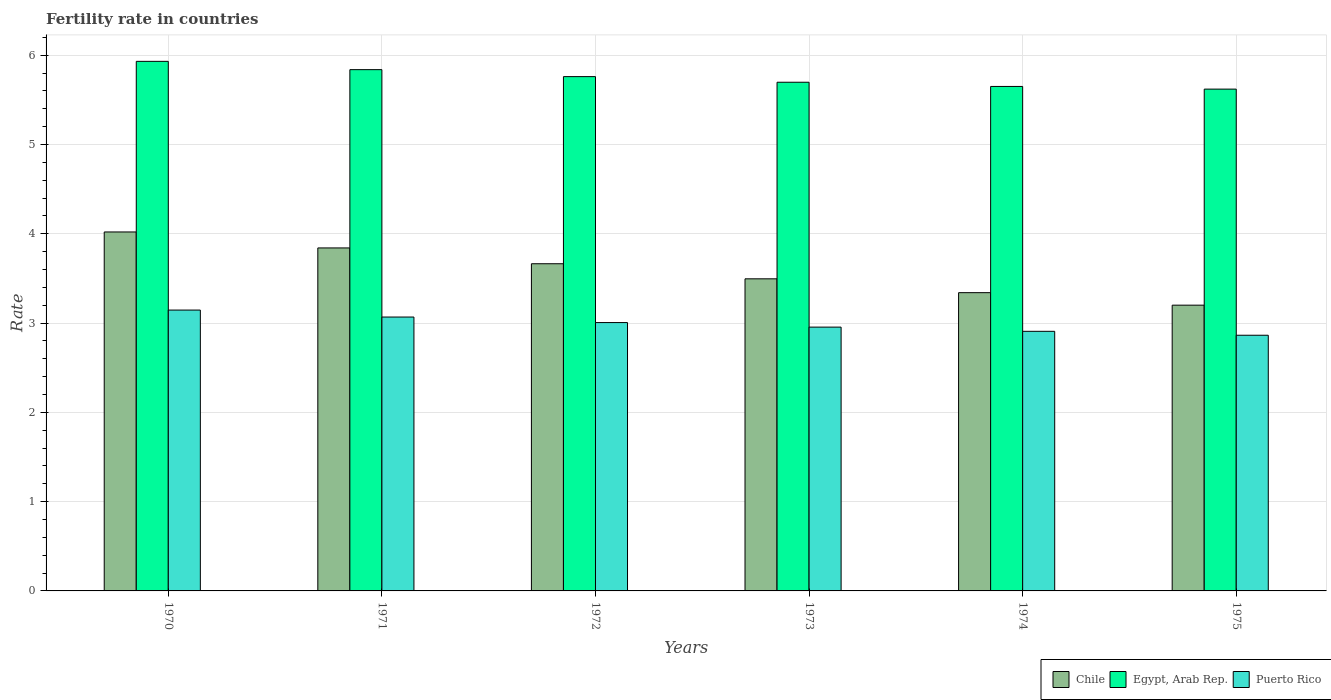How many different coloured bars are there?
Offer a very short reply. 3. Are the number of bars on each tick of the X-axis equal?
Keep it short and to the point. Yes. How many bars are there on the 3rd tick from the left?
Keep it short and to the point. 3. What is the fertility rate in Puerto Rico in 1973?
Give a very brief answer. 2.96. Across all years, what is the maximum fertility rate in Puerto Rico?
Your answer should be compact. 3.15. Across all years, what is the minimum fertility rate in Egypt, Arab Rep.?
Make the answer very short. 5.62. In which year was the fertility rate in Puerto Rico minimum?
Make the answer very short. 1975. What is the total fertility rate in Egypt, Arab Rep. in the graph?
Offer a terse response. 34.5. What is the difference between the fertility rate in Puerto Rico in 1972 and that in 1975?
Offer a terse response. 0.14. What is the difference between the fertility rate in Egypt, Arab Rep. in 1970 and the fertility rate in Puerto Rico in 1971?
Provide a succinct answer. 2.86. What is the average fertility rate in Puerto Rico per year?
Give a very brief answer. 2.99. In the year 1975, what is the difference between the fertility rate in Puerto Rico and fertility rate in Chile?
Keep it short and to the point. -0.34. In how many years, is the fertility rate in Chile greater than 4.8?
Offer a very short reply. 0. What is the ratio of the fertility rate in Chile in 1970 to that in 1975?
Your answer should be compact. 1.26. Is the fertility rate in Puerto Rico in 1971 less than that in 1974?
Offer a terse response. No. What is the difference between the highest and the second highest fertility rate in Chile?
Provide a succinct answer. 0.18. What is the difference between the highest and the lowest fertility rate in Chile?
Provide a succinct answer. 0.82. Is the sum of the fertility rate in Chile in 1971 and 1974 greater than the maximum fertility rate in Egypt, Arab Rep. across all years?
Ensure brevity in your answer.  Yes. What does the 3rd bar from the left in 1971 represents?
Your answer should be very brief. Puerto Rico. What does the 2nd bar from the right in 1975 represents?
Ensure brevity in your answer.  Egypt, Arab Rep. How many bars are there?
Give a very brief answer. 18. Are all the bars in the graph horizontal?
Provide a short and direct response. No. How many years are there in the graph?
Ensure brevity in your answer.  6. Are the values on the major ticks of Y-axis written in scientific E-notation?
Provide a succinct answer. No. Where does the legend appear in the graph?
Provide a short and direct response. Bottom right. How many legend labels are there?
Offer a terse response. 3. How are the legend labels stacked?
Your answer should be compact. Horizontal. What is the title of the graph?
Offer a very short reply. Fertility rate in countries. What is the label or title of the X-axis?
Your answer should be very brief. Years. What is the label or title of the Y-axis?
Your response must be concise. Rate. What is the Rate in Chile in 1970?
Provide a short and direct response. 4.02. What is the Rate in Egypt, Arab Rep. in 1970?
Provide a short and direct response. 5.93. What is the Rate of Puerto Rico in 1970?
Your response must be concise. 3.15. What is the Rate in Chile in 1971?
Make the answer very short. 3.84. What is the Rate in Egypt, Arab Rep. in 1971?
Keep it short and to the point. 5.84. What is the Rate in Puerto Rico in 1971?
Offer a very short reply. 3.07. What is the Rate in Chile in 1972?
Your response must be concise. 3.67. What is the Rate in Egypt, Arab Rep. in 1972?
Ensure brevity in your answer.  5.76. What is the Rate in Puerto Rico in 1972?
Ensure brevity in your answer.  3.01. What is the Rate of Chile in 1973?
Make the answer very short. 3.5. What is the Rate of Egypt, Arab Rep. in 1973?
Ensure brevity in your answer.  5.7. What is the Rate in Puerto Rico in 1973?
Offer a very short reply. 2.96. What is the Rate of Chile in 1974?
Offer a terse response. 3.34. What is the Rate in Egypt, Arab Rep. in 1974?
Offer a very short reply. 5.65. What is the Rate of Puerto Rico in 1974?
Your answer should be compact. 2.91. What is the Rate in Chile in 1975?
Offer a very short reply. 3.2. What is the Rate of Egypt, Arab Rep. in 1975?
Make the answer very short. 5.62. What is the Rate in Puerto Rico in 1975?
Offer a terse response. 2.86. Across all years, what is the maximum Rate of Chile?
Provide a succinct answer. 4.02. Across all years, what is the maximum Rate of Egypt, Arab Rep.?
Your response must be concise. 5.93. Across all years, what is the maximum Rate of Puerto Rico?
Provide a short and direct response. 3.15. Across all years, what is the minimum Rate of Chile?
Offer a very short reply. 3.2. Across all years, what is the minimum Rate in Egypt, Arab Rep.?
Offer a terse response. 5.62. Across all years, what is the minimum Rate in Puerto Rico?
Offer a very short reply. 2.86. What is the total Rate in Chile in the graph?
Offer a terse response. 21.57. What is the total Rate in Egypt, Arab Rep. in the graph?
Offer a very short reply. 34.5. What is the total Rate in Puerto Rico in the graph?
Offer a very short reply. 17.95. What is the difference between the Rate in Chile in 1970 and that in 1971?
Your answer should be compact. 0.18. What is the difference between the Rate of Egypt, Arab Rep. in 1970 and that in 1971?
Ensure brevity in your answer.  0.09. What is the difference between the Rate in Puerto Rico in 1970 and that in 1971?
Ensure brevity in your answer.  0.08. What is the difference between the Rate of Chile in 1970 and that in 1972?
Provide a short and direct response. 0.36. What is the difference between the Rate in Egypt, Arab Rep. in 1970 and that in 1972?
Keep it short and to the point. 0.17. What is the difference between the Rate of Puerto Rico in 1970 and that in 1972?
Make the answer very short. 0.14. What is the difference between the Rate in Chile in 1970 and that in 1973?
Your response must be concise. 0.53. What is the difference between the Rate in Egypt, Arab Rep. in 1970 and that in 1973?
Keep it short and to the point. 0.23. What is the difference between the Rate in Puerto Rico in 1970 and that in 1973?
Give a very brief answer. 0.19. What is the difference between the Rate in Chile in 1970 and that in 1974?
Offer a terse response. 0.68. What is the difference between the Rate of Egypt, Arab Rep. in 1970 and that in 1974?
Your answer should be very brief. 0.28. What is the difference between the Rate in Puerto Rico in 1970 and that in 1974?
Provide a short and direct response. 0.24. What is the difference between the Rate in Chile in 1970 and that in 1975?
Keep it short and to the point. 0.82. What is the difference between the Rate in Egypt, Arab Rep. in 1970 and that in 1975?
Offer a very short reply. 0.31. What is the difference between the Rate in Puerto Rico in 1970 and that in 1975?
Provide a short and direct response. 0.28. What is the difference between the Rate in Chile in 1971 and that in 1972?
Your answer should be compact. 0.18. What is the difference between the Rate in Egypt, Arab Rep. in 1971 and that in 1972?
Provide a succinct answer. 0.08. What is the difference between the Rate of Puerto Rico in 1971 and that in 1972?
Your answer should be very brief. 0.06. What is the difference between the Rate in Chile in 1971 and that in 1973?
Offer a terse response. 0.35. What is the difference between the Rate in Egypt, Arab Rep. in 1971 and that in 1973?
Your answer should be very brief. 0.14. What is the difference between the Rate of Puerto Rico in 1971 and that in 1973?
Your response must be concise. 0.11. What is the difference between the Rate in Chile in 1971 and that in 1974?
Your response must be concise. 0.5. What is the difference between the Rate of Egypt, Arab Rep. in 1971 and that in 1974?
Provide a succinct answer. 0.19. What is the difference between the Rate of Puerto Rico in 1971 and that in 1974?
Provide a succinct answer. 0.16. What is the difference between the Rate of Chile in 1971 and that in 1975?
Provide a short and direct response. 0.64. What is the difference between the Rate of Egypt, Arab Rep. in 1971 and that in 1975?
Offer a terse response. 0.22. What is the difference between the Rate of Puerto Rico in 1971 and that in 1975?
Offer a very short reply. 0.2. What is the difference between the Rate of Chile in 1972 and that in 1973?
Your answer should be compact. 0.17. What is the difference between the Rate in Egypt, Arab Rep. in 1972 and that in 1973?
Provide a succinct answer. 0.06. What is the difference between the Rate of Puerto Rico in 1972 and that in 1973?
Provide a short and direct response. 0.05. What is the difference between the Rate in Chile in 1972 and that in 1974?
Ensure brevity in your answer.  0.32. What is the difference between the Rate of Egypt, Arab Rep. in 1972 and that in 1974?
Your answer should be compact. 0.11. What is the difference between the Rate in Puerto Rico in 1972 and that in 1974?
Provide a short and direct response. 0.1. What is the difference between the Rate of Chile in 1972 and that in 1975?
Offer a terse response. 0.46. What is the difference between the Rate in Egypt, Arab Rep. in 1972 and that in 1975?
Ensure brevity in your answer.  0.14. What is the difference between the Rate in Puerto Rico in 1972 and that in 1975?
Offer a terse response. 0.14. What is the difference between the Rate of Chile in 1973 and that in 1974?
Keep it short and to the point. 0.15. What is the difference between the Rate in Egypt, Arab Rep. in 1973 and that in 1974?
Offer a very short reply. 0.05. What is the difference between the Rate of Puerto Rico in 1973 and that in 1974?
Ensure brevity in your answer.  0.05. What is the difference between the Rate of Chile in 1973 and that in 1975?
Offer a very short reply. 0.29. What is the difference between the Rate in Egypt, Arab Rep. in 1973 and that in 1975?
Your answer should be very brief. 0.08. What is the difference between the Rate of Puerto Rico in 1973 and that in 1975?
Ensure brevity in your answer.  0.09. What is the difference between the Rate of Chile in 1974 and that in 1975?
Give a very brief answer. 0.14. What is the difference between the Rate in Puerto Rico in 1974 and that in 1975?
Provide a succinct answer. 0.04. What is the difference between the Rate in Chile in 1970 and the Rate in Egypt, Arab Rep. in 1971?
Provide a succinct answer. -1.82. What is the difference between the Rate in Chile in 1970 and the Rate in Puerto Rico in 1971?
Offer a very short reply. 0.95. What is the difference between the Rate of Egypt, Arab Rep. in 1970 and the Rate of Puerto Rico in 1971?
Keep it short and to the point. 2.86. What is the difference between the Rate in Chile in 1970 and the Rate in Egypt, Arab Rep. in 1972?
Provide a succinct answer. -1.74. What is the difference between the Rate in Egypt, Arab Rep. in 1970 and the Rate in Puerto Rico in 1972?
Offer a very short reply. 2.93. What is the difference between the Rate in Chile in 1970 and the Rate in Egypt, Arab Rep. in 1973?
Make the answer very short. -1.68. What is the difference between the Rate in Chile in 1970 and the Rate in Puerto Rico in 1973?
Your response must be concise. 1.07. What is the difference between the Rate in Egypt, Arab Rep. in 1970 and the Rate in Puerto Rico in 1973?
Your response must be concise. 2.98. What is the difference between the Rate in Chile in 1970 and the Rate in Egypt, Arab Rep. in 1974?
Give a very brief answer. -1.63. What is the difference between the Rate of Chile in 1970 and the Rate of Puerto Rico in 1974?
Offer a very short reply. 1.11. What is the difference between the Rate of Egypt, Arab Rep. in 1970 and the Rate of Puerto Rico in 1974?
Your answer should be very brief. 3.02. What is the difference between the Rate in Chile in 1970 and the Rate in Puerto Rico in 1975?
Give a very brief answer. 1.16. What is the difference between the Rate in Egypt, Arab Rep. in 1970 and the Rate in Puerto Rico in 1975?
Make the answer very short. 3.07. What is the difference between the Rate in Chile in 1971 and the Rate in Egypt, Arab Rep. in 1972?
Give a very brief answer. -1.92. What is the difference between the Rate of Chile in 1971 and the Rate of Puerto Rico in 1972?
Keep it short and to the point. 0.84. What is the difference between the Rate in Egypt, Arab Rep. in 1971 and the Rate in Puerto Rico in 1972?
Offer a terse response. 2.83. What is the difference between the Rate of Chile in 1971 and the Rate of Egypt, Arab Rep. in 1973?
Give a very brief answer. -1.86. What is the difference between the Rate in Chile in 1971 and the Rate in Puerto Rico in 1973?
Offer a terse response. 0.89. What is the difference between the Rate of Egypt, Arab Rep. in 1971 and the Rate of Puerto Rico in 1973?
Your response must be concise. 2.88. What is the difference between the Rate in Chile in 1971 and the Rate in Egypt, Arab Rep. in 1974?
Make the answer very short. -1.81. What is the difference between the Rate in Chile in 1971 and the Rate in Puerto Rico in 1974?
Offer a very short reply. 0.93. What is the difference between the Rate of Egypt, Arab Rep. in 1971 and the Rate of Puerto Rico in 1974?
Your answer should be very brief. 2.93. What is the difference between the Rate in Chile in 1971 and the Rate in Egypt, Arab Rep. in 1975?
Offer a terse response. -1.78. What is the difference between the Rate of Chile in 1971 and the Rate of Puerto Rico in 1975?
Provide a short and direct response. 0.98. What is the difference between the Rate in Egypt, Arab Rep. in 1971 and the Rate in Puerto Rico in 1975?
Your answer should be compact. 2.98. What is the difference between the Rate in Chile in 1972 and the Rate in Egypt, Arab Rep. in 1973?
Your response must be concise. -2.03. What is the difference between the Rate in Chile in 1972 and the Rate in Puerto Rico in 1973?
Keep it short and to the point. 0.71. What is the difference between the Rate in Egypt, Arab Rep. in 1972 and the Rate in Puerto Rico in 1973?
Your answer should be compact. 2.81. What is the difference between the Rate in Chile in 1972 and the Rate in Egypt, Arab Rep. in 1974?
Provide a short and direct response. -1.99. What is the difference between the Rate in Chile in 1972 and the Rate in Puerto Rico in 1974?
Offer a very short reply. 0.76. What is the difference between the Rate in Egypt, Arab Rep. in 1972 and the Rate in Puerto Rico in 1974?
Ensure brevity in your answer.  2.85. What is the difference between the Rate of Chile in 1972 and the Rate of Egypt, Arab Rep. in 1975?
Provide a short and direct response. -1.96. What is the difference between the Rate of Chile in 1972 and the Rate of Puerto Rico in 1975?
Provide a succinct answer. 0.8. What is the difference between the Rate of Egypt, Arab Rep. in 1972 and the Rate of Puerto Rico in 1975?
Make the answer very short. 2.9. What is the difference between the Rate of Chile in 1973 and the Rate of Egypt, Arab Rep. in 1974?
Ensure brevity in your answer.  -2.15. What is the difference between the Rate of Chile in 1973 and the Rate of Puerto Rico in 1974?
Provide a succinct answer. 0.59. What is the difference between the Rate in Egypt, Arab Rep. in 1973 and the Rate in Puerto Rico in 1974?
Your answer should be very brief. 2.79. What is the difference between the Rate in Chile in 1973 and the Rate in Egypt, Arab Rep. in 1975?
Provide a succinct answer. -2.12. What is the difference between the Rate of Chile in 1973 and the Rate of Puerto Rico in 1975?
Provide a short and direct response. 0.63. What is the difference between the Rate in Egypt, Arab Rep. in 1973 and the Rate in Puerto Rico in 1975?
Your answer should be compact. 2.83. What is the difference between the Rate of Chile in 1974 and the Rate of Egypt, Arab Rep. in 1975?
Your response must be concise. -2.28. What is the difference between the Rate of Chile in 1974 and the Rate of Puerto Rico in 1975?
Your answer should be very brief. 0.48. What is the difference between the Rate of Egypt, Arab Rep. in 1974 and the Rate of Puerto Rico in 1975?
Provide a succinct answer. 2.79. What is the average Rate in Chile per year?
Make the answer very short. 3.59. What is the average Rate in Egypt, Arab Rep. per year?
Make the answer very short. 5.75. What is the average Rate of Puerto Rico per year?
Give a very brief answer. 2.99. In the year 1970, what is the difference between the Rate of Chile and Rate of Egypt, Arab Rep.?
Provide a succinct answer. -1.91. In the year 1970, what is the difference between the Rate of Chile and Rate of Puerto Rico?
Offer a very short reply. 0.88. In the year 1970, what is the difference between the Rate in Egypt, Arab Rep. and Rate in Puerto Rico?
Provide a short and direct response. 2.79. In the year 1971, what is the difference between the Rate of Chile and Rate of Egypt, Arab Rep.?
Make the answer very short. -2. In the year 1971, what is the difference between the Rate of Chile and Rate of Puerto Rico?
Offer a very short reply. 0.77. In the year 1971, what is the difference between the Rate in Egypt, Arab Rep. and Rate in Puerto Rico?
Ensure brevity in your answer.  2.77. In the year 1972, what is the difference between the Rate in Chile and Rate in Egypt, Arab Rep.?
Your response must be concise. -2.1. In the year 1972, what is the difference between the Rate in Chile and Rate in Puerto Rico?
Provide a succinct answer. 0.66. In the year 1972, what is the difference between the Rate of Egypt, Arab Rep. and Rate of Puerto Rico?
Offer a very short reply. 2.75. In the year 1973, what is the difference between the Rate in Chile and Rate in Egypt, Arab Rep.?
Your answer should be compact. -2.2. In the year 1973, what is the difference between the Rate of Chile and Rate of Puerto Rico?
Ensure brevity in your answer.  0.54. In the year 1973, what is the difference between the Rate in Egypt, Arab Rep. and Rate in Puerto Rico?
Your response must be concise. 2.74. In the year 1974, what is the difference between the Rate in Chile and Rate in Egypt, Arab Rep.?
Offer a terse response. -2.31. In the year 1974, what is the difference between the Rate in Chile and Rate in Puerto Rico?
Give a very brief answer. 0.43. In the year 1974, what is the difference between the Rate in Egypt, Arab Rep. and Rate in Puerto Rico?
Ensure brevity in your answer.  2.74. In the year 1975, what is the difference between the Rate in Chile and Rate in Egypt, Arab Rep.?
Your answer should be very brief. -2.42. In the year 1975, what is the difference between the Rate in Chile and Rate in Puerto Rico?
Keep it short and to the point. 0.34. In the year 1975, what is the difference between the Rate in Egypt, Arab Rep. and Rate in Puerto Rico?
Ensure brevity in your answer.  2.76. What is the ratio of the Rate of Chile in 1970 to that in 1971?
Your answer should be compact. 1.05. What is the ratio of the Rate of Egypt, Arab Rep. in 1970 to that in 1971?
Offer a terse response. 1.02. What is the ratio of the Rate in Puerto Rico in 1970 to that in 1971?
Keep it short and to the point. 1.03. What is the ratio of the Rate in Chile in 1970 to that in 1972?
Make the answer very short. 1.1. What is the ratio of the Rate of Egypt, Arab Rep. in 1970 to that in 1972?
Ensure brevity in your answer.  1.03. What is the ratio of the Rate of Puerto Rico in 1970 to that in 1972?
Make the answer very short. 1.05. What is the ratio of the Rate of Chile in 1970 to that in 1973?
Provide a short and direct response. 1.15. What is the ratio of the Rate in Egypt, Arab Rep. in 1970 to that in 1973?
Your answer should be very brief. 1.04. What is the ratio of the Rate of Puerto Rico in 1970 to that in 1973?
Give a very brief answer. 1.06. What is the ratio of the Rate in Chile in 1970 to that in 1974?
Offer a very short reply. 1.2. What is the ratio of the Rate of Egypt, Arab Rep. in 1970 to that in 1974?
Offer a very short reply. 1.05. What is the ratio of the Rate of Puerto Rico in 1970 to that in 1974?
Provide a succinct answer. 1.08. What is the ratio of the Rate of Chile in 1970 to that in 1975?
Provide a succinct answer. 1.26. What is the ratio of the Rate in Egypt, Arab Rep. in 1970 to that in 1975?
Provide a succinct answer. 1.06. What is the ratio of the Rate of Puerto Rico in 1970 to that in 1975?
Offer a very short reply. 1.1. What is the ratio of the Rate of Chile in 1971 to that in 1972?
Make the answer very short. 1.05. What is the ratio of the Rate in Egypt, Arab Rep. in 1971 to that in 1972?
Ensure brevity in your answer.  1.01. What is the ratio of the Rate in Puerto Rico in 1971 to that in 1972?
Your answer should be very brief. 1.02. What is the ratio of the Rate in Chile in 1971 to that in 1973?
Your answer should be very brief. 1.1. What is the ratio of the Rate of Egypt, Arab Rep. in 1971 to that in 1973?
Keep it short and to the point. 1.02. What is the ratio of the Rate in Puerto Rico in 1971 to that in 1973?
Provide a succinct answer. 1.04. What is the ratio of the Rate in Chile in 1971 to that in 1974?
Provide a short and direct response. 1.15. What is the ratio of the Rate in Puerto Rico in 1971 to that in 1974?
Ensure brevity in your answer.  1.05. What is the ratio of the Rate in Chile in 1971 to that in 1975?
Give a very brief answer. 1.2. What is the ratio of the Rate of Egypt, Arab Rep. in 1971 to that in 1975?
Offer a very short reply. 1.04. What is the ratio of the Rate of Puerto Rico in 1971 to that in 1975?
Give a very brief answer. 1.07. What is the ratio of the Rate in Chile in 1972 to that in 1973?
Make the answer very short. 1.05. What is the ratio of the Rate in Egypt, Arab Rep. in 1972 to that in 1973?
Provide a succinct answer. 1.01. What is the ratio of the Rate of Puerto Rico in 1972 to that in 1973?
Offer a terse response. 1.02. What is the ratio of the Rate of Chile in 1972 to that in 1974?
Make the answer very short. 1.1. What is the ratio of the Rate in Egypt, Arab Rep. in 1972 to that in 1974?
Give a very brief answer. 1.02. What is the ratio of the Rate in Puerto Rico in 1972 to that in 1974?
Your response must be concise. 1.03. What is the ratio of the Rate of Chile in 1972 to that in 1975?
Provide a short and direct response. 1.15. What is the ratio of the Rate in Egypt, Arab Rep. in 1972 to that in 1975?
Provide a short and direct response. 1.02. What is the ratio of the Rate of Puerto Rico in 1972 to that in 1975?
Make the answer very short. 1.05. What is the ratio of the Rate of Chile in 1973 to that in 1974?
Ensure brevity in your answer.  1.05. What is the ratio of the Rate of Egypt, Arab Rep. in 1973 to that in 1974?
Ensure brevity in your answer.  1.01. What is the ratio of the Rate in Puerto Rico in 1973 to that in 1974?
Ensure brevity in your answer.  1.02. What is the ratio of the Rate of Chile in 1973 to that in 1975?
Your response must be concise. 1.09. What is the ratio of the Rate of Egypt, Arab Rep. in 1973 to that in 1975?
Provide a succinct answer. 1.01. What is the ratio of the Rate of Puerto Rico in 1973 to that in 1975?
Your answer should be compact. 1.03. What is the ratio of the Rate in Chile in 1974 to that in 1975?
Offer a very short reply. 1.04. What is the ratio of the Rate in Puerto Rico in 1974 to that in 1975?
Offer a terse response. 1.02. What is the difference between the highest and the second highest Rate in Chile?
Ensure brevity in your answer.  0.18. What is the difference between the highest and the second highest Rate of Egypt, Arab Rep.?
Make the answer very short. 0.09. What is the difference between the highest and the second highest Rate of Puerto Rico?
Ensure brevity in your answer.  0.08. What is the difference between the highest and the lowest Rate in Chile?
Your answer should be compact. 0.82. What is the difference between the highest and the lowest Rate in Egypt, Arab Rep.?
Provide a short and direct response. 0.31. What is the difference between the highest and the lowest Rate in Puerto Rico?
Provide a succinct answer. 0.28. 